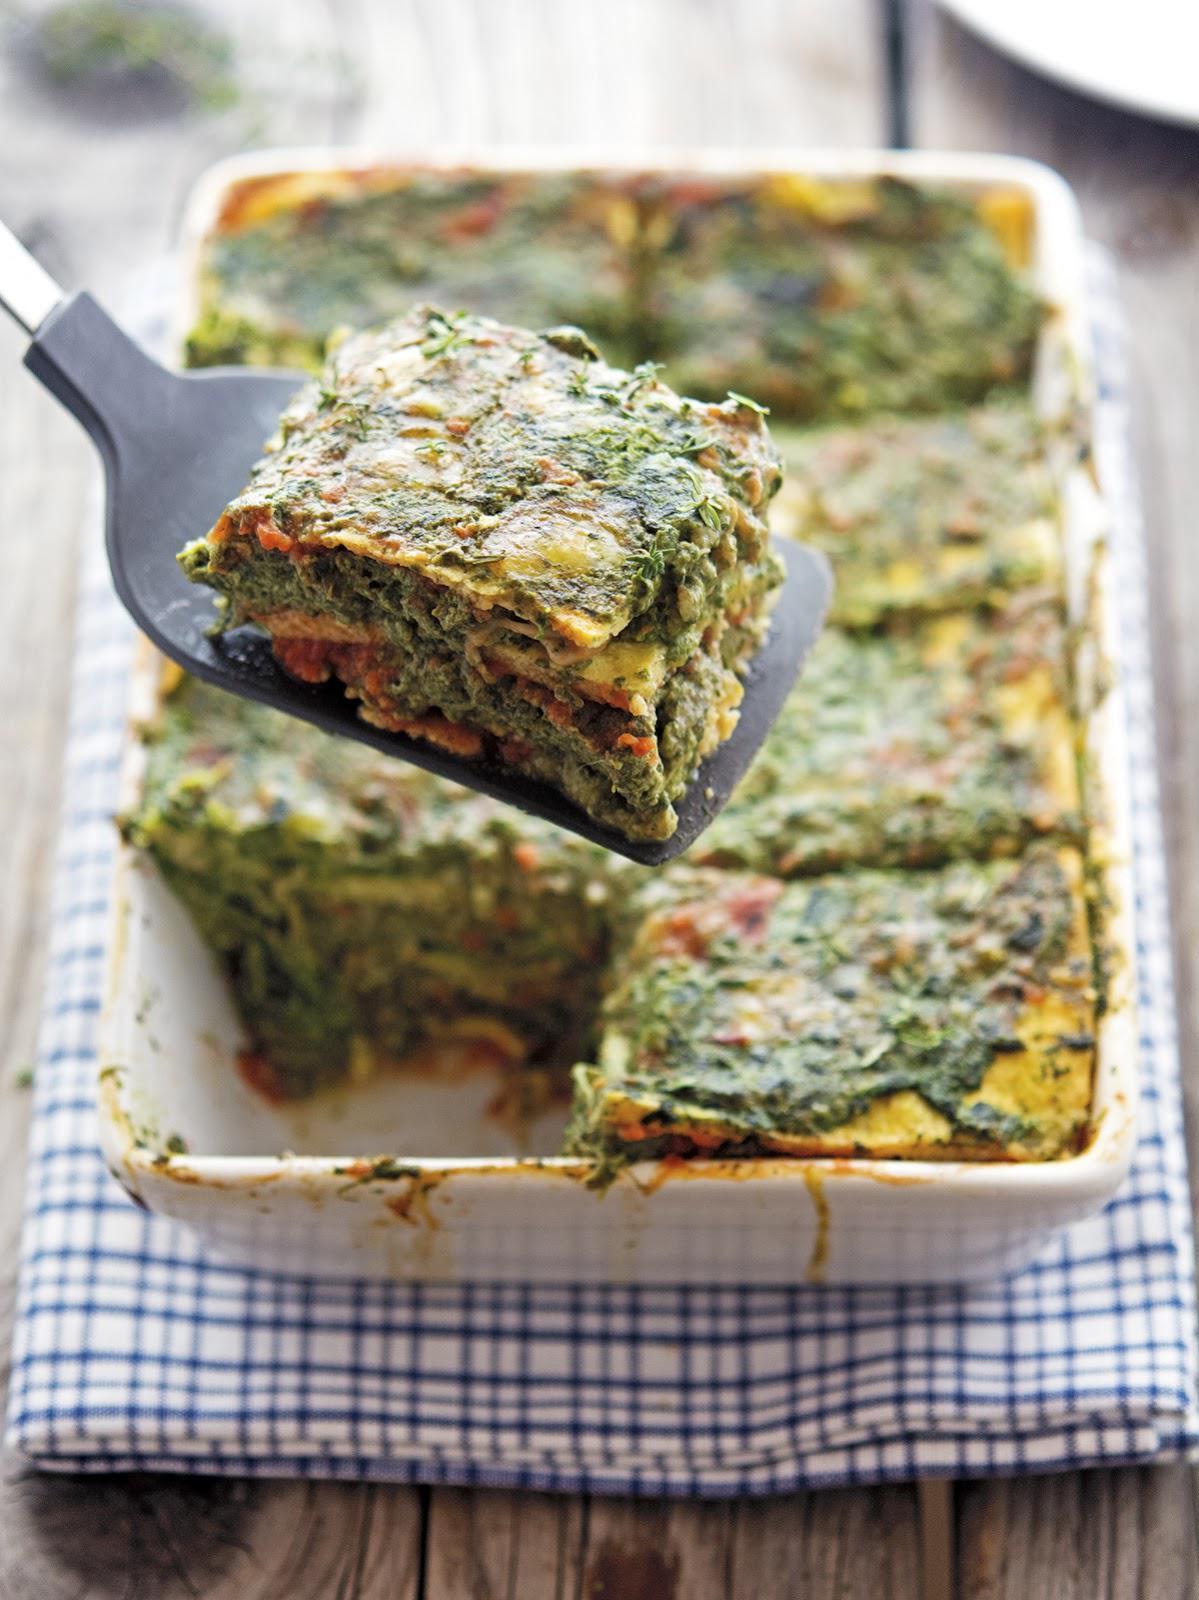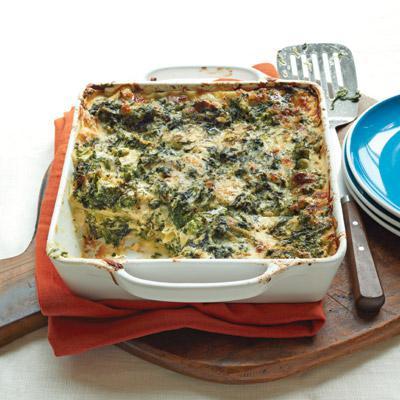The first image is the image on the left, the second image is the image on the right. Analyze the images presented: Is the assertion "Left image shows food served in a rectangular dish." valid? Answer yes or no. Yes. 